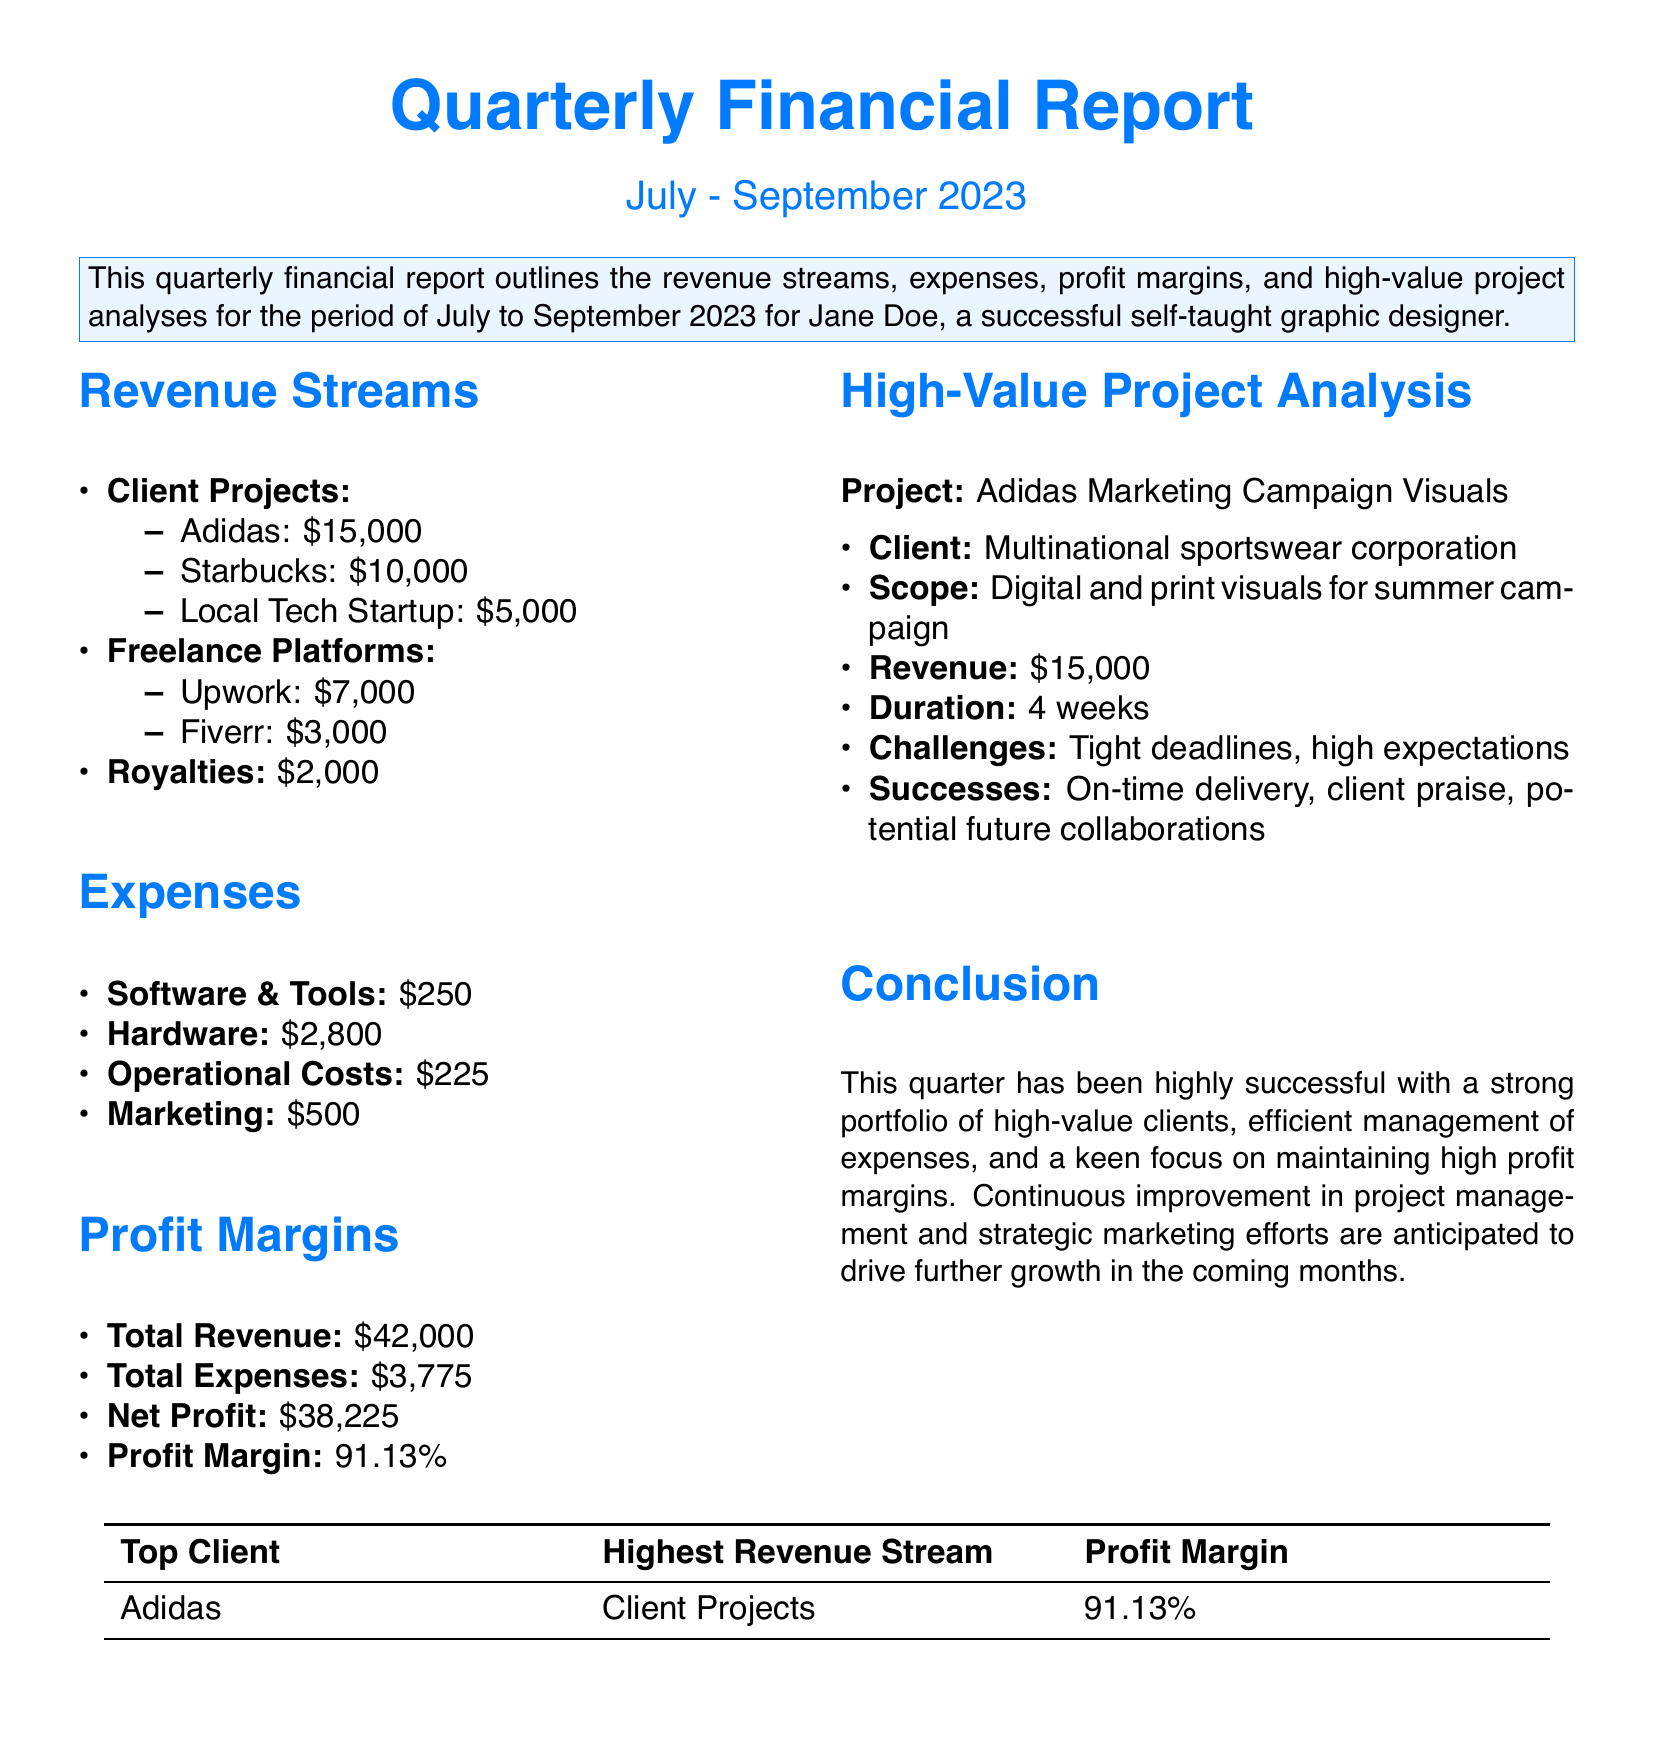what is the total revenue? The total revenue is calculated by adding all revenue sources listed in the document: $15,000 + $10,000 + $5,000 + $7,000 + $3,000 + $2,000 = $42,000.
Answer: $42,000 what are the total expenses? The total expenses are the sum of all expenses detailed in the document: $250 + $2,800 + $225 + $500 = $3,775.
Answer: $3,775 what is the net profit? The net profit is derived from subtracting total expenses from total revenue: $42,000 - $3,775 = $38,225.
Answer: $38,225 which client contributed the highest revenue? The document highlights that Adidas generated the highest revenue of $15,000.
Answer: Adidas what is the profit margin percentage? The profit margin is calculated as (Net Profit / Total Revenue) * 100, which results in (38,225 / 42,000) * 100 = 91.13%.
Answer: 91.13% how long did the Adidas project take to complete? The duration of the Adidas project, as mentioned in the document, is 4 weeks.
Answer: 4 weeks what was the main challenge faced in the Adidas project? The document states that the main challenge was tight deadlines and high expectations.
Answer: Tight deadlines what is the highest revenue stream categorized in the report? According to the report, the highest revenue stream comes from Client Projects.
Answer: Client Projects which platform generated $3,000 in revenue? The document indicates that Fiverr was the platform that generated $3,000.
Answer: Fiverr 